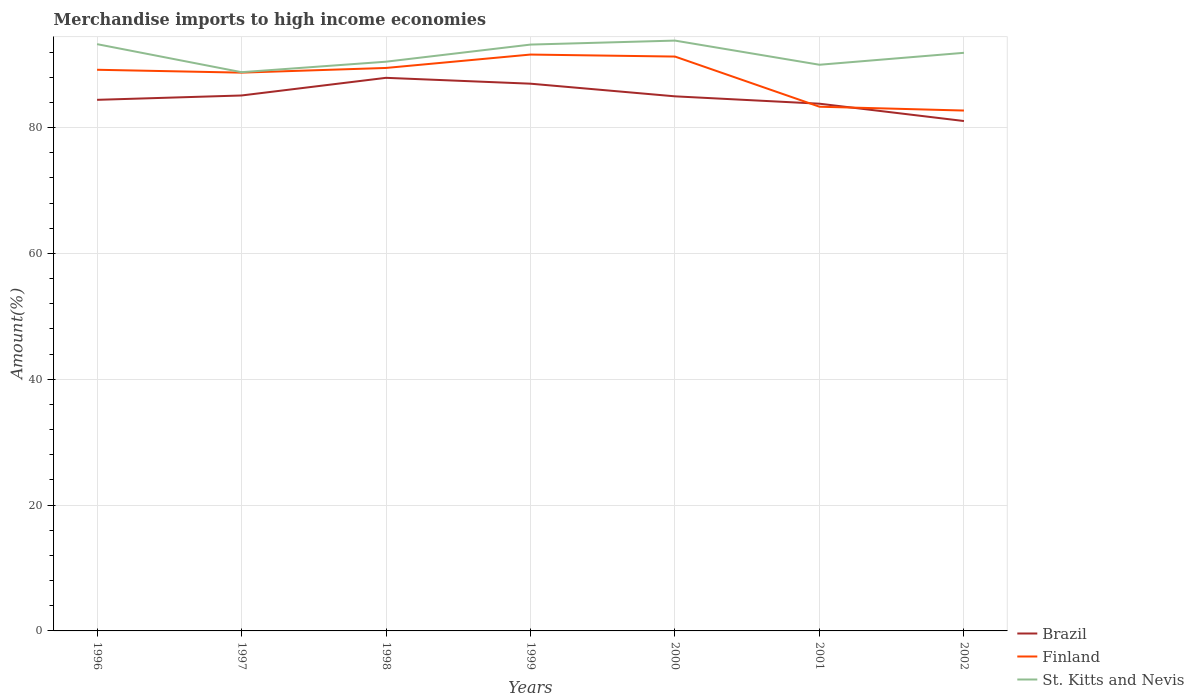How many different coloured lines are there?
Make the answer very short. 3. Does the line corresponding to Brazil intersect with the line corresponding to Finland?
Your response must be concise. Yes. Across all years, what is the maximum percentage of amount earned from merchandise imports in St. Kitts and Nevis?
Offer a terse response. 88.8. In which year was the percentage of amount earned from merchandise imports in Brazil maximum?
Offer a terse response. 2002. What is the total percentage of amount earned from merchandise imports in Brazil in the graph?
Your response must be concise. 0.14. What is the difference between the highest and the second highest percentage of amount earned from merchandise imports in St. Kitts and Nevis?
Your answer should be compact. 5.02. How many lines are there?
Provide a short and direct response. 3. How many years are there in the graph?
Keep it short and to the point. 7. Where does the legend appear in the graph?
Your response must be concise. Bottom right. How many legend labels are there?
Offer a terse response. 3. What is the title of the graph?
Your answer should be very brief. Merchandise imports to high income economies. What is the label or title of the X-axis?
Your answer should be compact. Years. What is the label or title of the Y-axis?
Ensure brevity in your answer.  Amount(%). What is the Amount(%) of Brazil in 1996?
Provide a short and direct response. 84.4. What is the Amount(%) of Finland in 1996?
Offer a very short reply. 89.18. What is the Amount(%) in St. Kitts and Nevis in 1996?
Your response must be concise. 93.25. What is the Amount(%) of Brazil in 1997?
Provide a short and direct response. 85.1. What is the Amount(%) of Finland in 1997?
Provide a succinct answer. 88.73. What is the Amount(%) in St. Kitts and Nevis in 1997?
Your response must be concise. 88.8. What is the Amount(%) in Brazil in 1998?
Make the answer very short. 87.9. What is the Amount(%) of Finland in 1998?
Offer a very short reply. 89.47. What is the Amount(%) in St. Kitts and Nevis in 1998?
Give a very brief answer. 90.46. What is the Amount(%) of Brazil in 1999?
Give a very brief answer. 86.97. What is the Amount(%) in Finland in 1999?
Your response must be concise. 91.6. What is the Amount(%) of St. Kitts and Nevis in 1999?
Your answer should be compact. 93.18. What is the Amount(%) in Brazil in 2000?
Your response must be concise. 84.96. What is the Amount(%) in Finland in 2000?
Provide a short and direct response. 91.28. What is the Amount(%) in St. Kitts and Nevis in 2000?
Ensure brevity in your answer.  93.82. What is the Amount(%) of Brazil in 2001?
Offer a very short reply. 83.79. What is the Amount(%) of Finland in 2001?
Give a very brief answer. 83.31. What is the Amount(%) in St. Kitts and Nevis in 2001?
Provide a succinct answer. 89.98. What is the Amount(%) of Brazil in 2002?
Offer a terse response. 81.04. What is the Amount(%) of Finland in 2002?
Give a very brief answer. 82.7. What is the Amount(%) of St. Kitts and Nevis in 2002?
Your answer should be very brief. 91.88. Across all years, what is the maximum Amount(%) in Brazil?
Your response must be concise. 87.9. Across all years, what is the maximum Amount(%) of Finland?
Provide a short and direct response. 91.6. Across all years, what is the maximum Amount(%) of St. Kitts and Nevis?
Provide a short and direct response. 93.82. Across all years, what is the minimum Amount(%) of Brazil?
Your answer should be very brief. 81.04. Across all years, what is the minimum Amount(%) of Finland?
Provide a succinct answer. 82.7. Across all years, what is the minimum Amount(%) of St. Kitts and Nevis?
Your answer should be very brief. 88.8. What is the total Amount(%) of Brazil in the graph?
Ensure brevity in your answer.  594.15. What is the total Amount(%) in Finland in the graph?
Give a very brief answer. 616.27. What is the total Amount(%) of St. Kitts and Nevis in the graph?
Give a very brief answer. 641.38. What is the difference between the Amount(%) in Brazil in 1996 and that in 1997?
Provide a succinct answer. -0.69. What is the difference between the Amount(%) in Finland in 1996 and that in 1997?
Your response must be concise. 0.46. What is the difference between the Amount(%) in St. Kitts and Nevis in 1996 and that in 1997?
Your answer should be very brief. 4.45. What is the difference between the Amount(%) of Brazil in 1996 and that in 1998?
Your answer should be very brief. -3.5. What is the difference between the Amount(%) of Finland in 1996 and that in 1998?
Provide a short and direct response. -0.29. What is the difference between the Amount(%) in St. Kitts and Nevis in 1996 and that in 1998?
Provide a short and direct response. 2.79. What is the difference between the Amount(%) of Brazil in 1996 and that in 1999?
Offer a terse response. -2.56. What is the difference between the Amount(%) of Finland in 1996 and that in 1999?
Keep it short and to the point. -2.42. What is the difference between the Amount(%) in St. Kitts and Nevis in 1996 and that in 1999?
Provide a short and direct response. 0.07. What is the difference between the Amount(%) of Brazil in 1996 and that in 2000?
Offer a very short reply. -0.56. What is the difference between the Amount(%) in Finland in 1996 and that in 2000?
Offer a terse response. -2.1. What is the difference between the Amount(%) in St. Kitts and Nevis in 1996 and that in 2000?
Give a very brief answer. -0.56. What is the difference between the Amount(%) in Brazil in 1996 and that in 2001?
Keep it short and to the point. 0.62. What is the difference between the Amount(%) in Finland in 1996 and that in 2001?
Your answer should be very brief. 5.87. What is the difference between the Amount(%) in St. Kitts and Nevis in 1996 and that in 2001?
Provide a short and direct response. 3.27. What is the difference between the Amount(%) of Brazil in 1996 and that in 2002?
Provide a short and direct response. 3.37. What is the difference between the Amount(%) in Finland in 1996 and that in 2002?
Ensure brevity in your answer.  6.48. What is the difference between the Amount(%) of St. Kitts and Nevis in 1996 and that in 2002?
Offer a terse response. 1.38. What is the difference between the Amount(%) in Brazil in 1997 and that in 1998?
Provide a short and direct response. -2.81. What is the difference between the Amount(%) of Finland in 1997 and that in 1998?
Offer a very short reply. -0.75. What is the difference between the Amount(%) of St. Kitts and Nevis in 1997 and that in 1998?
Provide a short and direct response. -1.67. What is the difference between the Amount(%) in Brazil in 1997 and that in 1999?
Offer a very short reply. -1.87. What is the difference between the Amount(%) of Finland in 1997 and that in 1999?
Ensure brevity in your answer.  -2.87. What is the difference between the Amount(%) of St. Kitts and Nevis in 1997 and that in 1999?
Ensure brevity in your answer.  -4.39. What is the difference between the Amount(%) of Brazil in 1997 and that in 2000?
Make the answer very short. 0.14. What is the difference between the Amount(%) of Finland in 1997 and that in 2000?
Provide a short and direct response. -2.55. What is the difference between the Amount(%) in St. Kitts and Nevis in 1997 and that in 2000?
Give a very brief answer. -5.02. What is the difference between the Amount(%) of Brazil in 1997 and that in 2001?
Your answer should be very brief. 1.31. What is the difference between the Amount(%) of Finland in 1997 and that in 2001?
Offer a terse response. 5.42. What is the difference between the Amount(%) of St. Kitts and Nevis in 1997 and that in 2001?
Provide a short and direct response. -1.18. What is the difference between the Amount(%) of Brazil in 1997 and that in 2002?
Provide a succinct answer. 4.06. What is the difference between the Amount(%) in Finland in 1997 and that in 2002?
Give a very brief answer. 6.02. What is the difference between the Amount(%) in St. Kitts and Nevis in 1997 and that in 2002?
Ensure brevity in your answer.  -3.08. What is the difference between the Amount(%) of Brazil in 1998 and that in 1999?
Provide a succinct answer. 0.93. What is the difference between the Amount(%) in Finland in 1998 and that in 1999?
Keep it short and to the point. -2.13. What is the difference between the Amount(%) of St. Kitts and Nevis in 1998 and that in 1999?
Provide a short and direct response. -2.72. What is the difference between the Amount(%) of Brazil in 1998 and that in 2000?
Offer a terse response. 2.94. What is the difference between the Amount(%) in Finland in 1998 and that in 2000?
Offer a very short reply. -1.81. What is the difference between the Amount(%) in St. Kitts and Nevis in 1998 and that in 2000?
Provide a short and direct response. -3.35. What is the difference between the Amount(%) of Brazil in 1998 and that in 2001?
Provide a short and direct response. 4.11. What is the difference between the Amount(%) in Finland in 1998 and that in 2001?
Keep it short and to the point. 6.16. What is the difference between the Amount(%) of St. Kitts and Nevis in 1998 and that in 2001?
Make the answer very short. 0.48. What is the difference between the Amount(%) in Brazil in 1998 and that in 2002?
Ensure brevity in your answer.  6.87. What is the difference between the Amount(%) in Finland in 1998 and that in 2002?
Make the answer very short. 6.77. What is the difference between the Amount(%) of St. Kitts and Nevis in 1998 and that in 2002?
Your answer should be compact. -1.41. What is the difference between the Amount(%) of Brazil in 1999 and that in 2000?
Provide a succinct answer. 2.01. What is the difference between the Amount(%) in Finland in 1999 and that in 2000?
Provide a succinct answer. 0.32. What is the difference between the Amount(%) in St. Kitts and Nevis in 1999 and that in 2000?
Your response must be concise. -0.63. What is the difference between the Amount(%) of Brazil in 1999 and that in 2001?
Your answer should be compact. 3.18. What is the difference between the Amount(%) of Finland in 1999 and that in 2001?
Offer a very short reply. 8.29. What is the difference between the Amount(%) of St. Kitts and Nevis in 1999 and that in 2001?
Provide a short and direct response. 3.2. What is the difference between the Amount(%) of Brazil in 1999 and that in 2002?
Your response must be concise. 5.93. What is the difference between the Amount(%) in Finland in 1999 and that in 2002?
Ensure brevity in your answer.  8.9. What is the difference between the Amount(%) of St. Kitts and Nevis in 1999 and that in 2002?
Offer a very short reply. 1.31. What is the difference between the Amount(%) of Brazil in 2000 and that in 2001?
Provide a succinct answer. 1.17. What is the difference between the Amount(%) of Finland in 2000 and that in 2001?
Your answer should be very brief. 7.97. What is the difference between the Amount(%) in St. Kitts and Nevis in 2000 and that in 2001?
Provide a succinct answer. 3.84. What is the difference between the Amount(%) in Brazil in 2000 and that in 2002?
Give a very brief answer. 3.92. What is the difference between the Amount(%) of Finland in 2000 and that in 2002?
Your answer should be very brief. 8.58. What is the difference between the Amount(%) of St. Kitts and Nevis in 2000 and that in 2002?
Make the answer very short. 1.94. What is the difference between the Amount(%) in Brazil in 2001 and that in 2002?
Provide a succinct answer. 2.75. What is the difference between the Amount(%) in Finland in 2001 and that in 2002?
Offer a terse response. 0.61. What is the difference between the Amount(%) of St. Kitts and Nevis in 2001 and that in 2002?
Provide a succinct answer. -1.9. What is the difference between the Amount(%) of Brazil in 1996 and the Amount(%) of Finland in 1997?
Offer a terse response. -4.32. What is the difference between the Amount(%) in Brazil in 1996 and the Amount(%) in St. Kitts and Nevis in 1997?
Keep it short and to the point. -4.39. What is the difference between the Amount(%) in Finland in 1996 and the Amount(%) in St. Kitts and Nevis in 1997?
Give a very brief answer. 0.38. What is the difference between the Amount(%) in Brazil in 1996 and the Amount(%) in Finland in 1998?
Your response must be concise. -5.07. What is the difference between the Amount(%) in Brazil in 1996 and the Amount(%) in St. Kitts and Nevis in 1998?
Offer a terse response. -6.06. What is the difference between the Amount(%) in Finland in 1996 and the Amount(%) in St. Kitts and Nevis in 1998?
Provide a succinct answer. -1.28. What is the difference between the Amount(%) of Brazil in 1996 and the Amount(%) of Finland in 1999?
Your response must be concise. -7.2. What is the difference between the Amount(%) of Brazil in 1996 and the Amount(%) of St. Kitts and Nevis in 1999?
Provide a short and direct response. -8.78. What is the difference between the Amount(%) in Finland in 1996 and the Amount(%) in St. Kitts and Nevis in 1999?
Offer a terse response. -4. What is the difference between the Amount(%) of Brazil in 1996 and the Amount(%) of Finland in 2000?
Your answer should be compact. -6.88. What is the difference between the Amount(%) in Brazil in 1996 and the Amount(%) in St. Kitts and Nevis in 2000?
Provide a short and direct response. -9.41. What is the difference between the Amount(%) of Finland in 1996 and the Amount(%) of St. Kitts and Nevis in 2000?
Offer a terse response. -4.64. What is the difference between the Amount(%) in Brazil in 1996 and the Amount(%) in Finland in 2001?
Keep it short and to the point. 1.09. What is the difference between the Amount(%) of Brazil in 1996 and the Amount(%) of St. Kitts and Nevis in 2001?
Provide a short and direct response. -5.58. What is the difference between the Amount(%) of Finland in 1996 and the Amount(%) of St. Kitts and Nevis in 2001?
Provide a short and direct response. -0.8. What is the difference between the Amount(%) of Brazil in 1996 and the Amount(%) of Finland in 2002?
Your response must be concise. 1.7. What is the difference between the Amount(%) in Brazil in 1996 and the Amount(%) in St. Kitts and Nevis in 2002?
Your response must be concise. -7.47. What is the difference between the Amount(%) in Finland in 1996 and the Amount(%) in St. Kitts and Nevis in 2002?
Make the answer very short. -2.7. What is the difference between the Amount(%) in Brazil in 1997 and the Amount(%) in Finland in 1998?
Your answer should be very brief. -4.38. What is the difference between the Amount(%) in Brazil in 1997 and the Amount(%) in St. Kitts and Nevis in 1998?
Ensure brevity in your answer.  -5.37. What is the difference between the Amount(%) in Finland in 1997 and the Amount(%) in St. Kitts and Nevis in 1998?
Your answer should be compact. -1.74. What is the difference between the Amount(%) in Brazil in 1997 and the Amount(%) in Finland in 1999?
Offer a terse response. -6.5. What is the difference between the Amount(%) in Brazil in 1997 and the Amount(%) in St. Kitts and Nevis in 1999?
Give a very brief answer. -8.09. What is the difference between the Amount(%) of Finland in 1997 and the Amount(%) of St. Kitts and Nevis in 1999?
Provide a succinct answer. -4.46. What is the difference between the Amount(%) in Brazil in 1997 and the Amount(%) in Finland in 2000?
Your response must be concise. -6.18. What is the difference between the Amount(%) of Brazil in 1997 and the Amount(%) of St. Kitts and Nevis in 2000?
Ensure brevity in your answer.  -8.72. What is the difference between the Amount(%) in Finland in 1997 and the Amount(%) in St. Kitts and Nevis in 2000?
Provide a short and direct response. -5.09. What is the difference between the Amount(%) in Brazil in 1997 and the Amount(%) in Finland in 2001?
Offer a terse response. 1.79. What is the difference between the Amount(%) of Brazil in 1997 and the Amount(%) of St. Kitts and Nevis in 2001?
Ensure brevity in your answer.  -4.88. What is the difference between the Amount(%) in Finland in 1997 and the Amount(%) in St. Kitts and Nevis in 2001?
Your response must be concise. -1.25. What is the difference between the Amount(%) in Brazil in 1997 and the Amount(%) in Finland in 2002?
Give a very brief answer. 2.39. What is the difference between the Amount(%) in Brazil in 1997 and the Amount(%) in St. Kitts and Nevis in 2002?
Your answer should be very brief. -6.78. What is the difference between the Amount(%) in Finland in 1997 and the Amount(%) in St. Kitts and Nevis in 2002?
Offer a very short reply. -3.15. What is the difference between the Amount(%) in Brazil in 1998 and the Amount(%) in Finland in 1999?
Offer a terse response. -3.7. What is the difference between the Amount(%) of Brazil in 1998 and the Amount(%) of St. Kitts and Nevis in 1999?
Ensure brevity in your answer.  -5.28. What is the difference between the Amount(%) of Finland in 1998 and the Amount(%) of St. Kitts and Nevis in 1999?
Your answer should be compact. -3.71. What is the difference between the Amount(%) in Brazil in 1998 and the Amount(%) in Finland in 2000?
Make the answer very short. -3.38. What is the difference between the Amount(%) of Brazil in 1998 and the Amount(%) of St. Kitts and Nevis in 2000?
Make the answer very short. -5.92. What is the difference between the Amount(%) in Finland in 1998 and the Amount(%) in St. Kitts and Nevis in 2000?
Your response must be concise. -4.35. What is the difference between the Amount(%) in Brazil in 1998 and the Amount(%) in Finland in 2001?
Your answer should be compact. 4.59. What is the difference between the Amount(%) in Brazil in 1998 and the Amount(%) in St. Kitts and Nevis in 2001?
Your response must be concise. -2.08. What is the difference between the Amount(%) of Finland in 1998 and the Amount(%) of St. Kitts and Nevis in 2001?
Ensure brevity in your answer.  -0.51. What is the difference between the Amount(%) in Brazil in 1998 and the Amount(%) in Finland in 2002?
Your response must be concise. 5.2. What is the difference between the Amount(%) of Brazil in 1998 and the Amount(%) of St. Kitts and Nevis in 2002?
Keep it short and to the point. -3.98. What is the difference between the Amount(%) of Finland in 1998 and the Amount(%) of St. Kitts and Nevis in 2002?
Offer a terse response. -2.41. What is the difference between the Amount(%) in Brazil in 1999 and the Amount(%) in Finland in 2000?
Make the answer very short. -4.31. What is the difference between the Amount(%) in Brazil in 1999 and the Amount(%) in St. Kitts and Nevis in 2000?
Ensure brevity in your answer.  -6.85. What is the difference between the Amount(%) in Finland in 1999 and the Amount(%) in St. Kitts and Nevis in 2000?
Keep it short and to the point. -2.22. What is the difference between the Amount(%) in Brazil in 1999 and the Amount(%) in Finland in 2001?
Offer a terse response. 3.66. What is the difference between the Amount(%) in Brazil in 1999 and the Amount(%) in St. Kitts and Nevis in 2001?
Provide a short and direct response. -3.01. What is the difference between the Amount(%) of Finland in 1999 and the Amount(%) of St. Kitts and Nevis in 2001?
Provide a succinct answer. 1.62. What is the difference between the Amount(%) of Brazil in 1999 and the Amount(%) of Finland in 2002?
Offer a terse response. 4.27. What is the difference between the Amount(%) of Brazil in 1999 and the Amount(%) of St. Kitts and Nevis in 2002?
Give a very brief answer. -4.91. What is the difference between the Amount(%) of Finland in 1999 and the Amount(%) of St. Kitts and Nevis in 2002?
Offer a very short reply. -0.28. What is the difference between the Amount(%) of Brazil in 2000 and the Amount(%) of Finland in 2001?
Provide a succinct answer. 1.65. What is the difference between the Amount(%) in Brazil in 2000 and the Amount(%) in St. Kitts and Nevis in 2001?
Provide a short and direct response. -5.02. What is the difference between the Amount(%) in Finland in 2000 and the Amount(%) in St. Kitts and Nevis in 2001?
Ensure brevity in your answer.  1.3. What is the difference between the Amount(%) in Brazil in 2000 and the Amount(%) in Finland in 2002?
Your answer should be very brief. 2.26. What is the difference between the Amount(%) of Brazil in 2000 and the Amount(%) of St. Kitts and Nevis in 2002?
Ensure brevity in your answer.  -6.92. What is the difference between the Amount(%) in Finland in 2000 and the Amount(%) in St. Kitts and Nevis in 2002?
Ensure brevity in your answer.  -0.6. What is the difference between the Amount(%) in Brazil in 2001 and the Amount(%) in Finland in 2002?
Your answer should be very brief. 1.09. What is the difference between the Amount(%) in Brazil in 2001 and the Amount(%) in St. Kitts and Nevis in 2002?
Offer a very short reply. -8.09. What is the difference between the Amount(%) in Finland in 2001 and the Amount(%) in St. Kitts and Nevis in 2002?
Give a very brief answer. -8.57. What is the average Amount(%) of Brazil per year?
Keep it short and to the point. 84.88. What is the average Amount(%) in Finland per year?
Your answer should be compact. 88.04. What is the average Amount(%) of St. Kitts and Nevis per year?
Make the answer very short. 91.63. In the year 1996, what is the difference between the Amount(%) of Brazil and Amount(%) of Finland?
Provide a succinct answer. -4.78. In the year 1996, what is the difference between the Amount(%) in Brazil and Amount(%) in St. Kitts and Nevis?
Provide a succinct answer. -8.85. In the year 1996, what is the difference between the Amount(%) in Finland and Amount(%) in St. Kitts and Nevis?
Give a very brief answer. -4.07. In the year 1997, what is the difference between the Amount(%) of Brazil and Amount(%) of Finland?
Ensure brevity in your answer.  -3.63. In the year 1997, what is the difference between the Amount(%) of Brazil and Amount(%) of St. Kitts and Nevis?
Give a very brief answer. -3.7. In the year 1997, what is the difference between the Amount(%) of Finland and Amount(%) of St. Kitts and Nevis?
Your answer should be very brief. -0.07. In the year 1998, what is the difference between the Amount(%) in Brazil and Amount(%) in Finland?
Keep it short and to the point. -1.57. In the year 1998, what is the difference between the Amount(%) in Brazil and Amount(%) in St. Kitts and Nevis?
Offer a terse response. -2.56. In the year 1998, what is the difference between the Amount(%) of Finland and Amount(%) of St. Kitts and Nevis?
Offer a very short reply. -0.99. In the year 1999, what is the difference between the Amount(%) in Brazil and Amount(%) in Finland?
Provide a short and direct response. -4.63. In the year 1999, what is the difference between the Amount(%) of Brazil and Amount(%) of St. Kitts and Nevis?
Your response must be concise. -6.21. In the year 1999, what is the difference between the Amount(%) of Finland and Amount(%) of St. Kitts and Nevis?
Ensure brevity in your answer.  -1.58. In the year 2000, what is the difference between the Amount(%) of Brazil and Amount(%) of Finland?
Provide a short and direct response. -6.32. In the year 2000, what is the difference between the Amount(%) of Brazil and Amount(%) of St. Kitts and Nevis?
Provide a short and direct response. -8.86. In the year 2000, what is the difference between the Amount(%) of Finland and Amount(%) of St. Kitts and Nevis?
Your answer should be very brief. -2.54. In the year 2001, what is the difference between the Amount(%) in Brazil and Amount(%) in Finland?
Your answer should be very brief. 0.48. In the year 2001, what is the difference between the Amount(%) in Brazil and Amount(%) in St. Kitts and Nevis?
Your answer should be compact. -6.19. In the year 2001, what is the difference between the Amount(%) of Finland and Amount(%) of St. Kitts and Nevis?
Offer a terse response. -6.67. In the year 2002, what is the difference between the Amount(%) in Brazil and Amount(%) in Finland?
Your answer should be compact. -1.67. In the year 2002, what is the difference between the Amount(%) in Brazil and Amount(%) in St. Kitts and Nevis?
Provide a succinct answer. -10.84. In the year 2002, what is the difference between the Amount(%) of Finland and Amount(%) of St. Kitts and Nevis?
Your answer should be compact. -9.18. What is the ratio of the Amount(%) in Brazil in 1996 to that in 1997?
Your response must be concise. 0.99. What is the ratio of the Amount(%) in Finland in 1996 to that in 1997?
Ensure brevity in your answer.  1.01. What is the ratio of the Amount(%) in St. Kitts and Nevis in 1996 to that in 1997?
Ensure brevity in your answer.  1.05. What is the ratio of the Amount(%) in Brazil in 1996 to that in 1998?
Offer a terse response. 0.96. What is the ratio of the Amount(%) of Finland in 1996 to that in 1998?
Provide a succinct answer. 1. What is the ratio of the Amount(%) in St. Kitts and Nevis in 1996 to that in 1998?
Ensure brevity in your answer.  1.03. What is the ratio of the Amount(%) of Brazil in 1996 to that in 1999?
Your response must be concise. 0.97. What is the ratio of the Amount(%) in Finland in 1996 to that in 1999?
Make the answer very short. 0.97. What is the ratio of the Amount(%) of St. Kitts and Nevis in 1996 to that in 2000?
Your answer should be compact. 0.99. What is the ratio of the Amount(%) in Brazil in 1996 to that in 2001?
Make the answer very short. 1.01. What is the ratio of the Amount(%) in Finland in 1996 to that in 2001?
Ensure brevity in your answer.  1.07. What is the ratio of the Amount(%) in St. Kitts and Nevis in 1996 to that in 2001?
Ensure brevity in your answer.  1.04. What is the ratio of the Amount(%) of Brazil in 1996 to that in 2002?
Keep it short and to the point. 1.04. What is the ratio of the Amount(%) of Finland in 1996 to that in 2002?
Provide a succinct answer. 1.08. What is the ratio of the Amount(%) of Brazil in 1997 to that in 1998?
Offer a terse response. 0.97. What is the ratio of the Amount(%) in St. Kitts and Nevis in 1997 to that in 1998?
Give a very brief answer. 0.98. What is the ratio of the Amount(%) of Brazil in 1997 to that in 1999?
Offer a very short reply. 0.98. What is the ratio of the Amount(%) of Finland in 1997 to that in 1999?
Keep it short and to the point. 0.97. What is the ratio of the Amount(%) of St. Kitts and Nevis in 1997 to that in 1999?
Ensure brevity in your answer.  0.95. What is the ratio of the Amount(%) of Brazil in 1997 to that in 2000?
Your response must be concise. 1. What is the ratio of the Amount(%) in St. Kitts and Nevis in 1997 to that in 2000?
Your answer should be very brief. 0.95. What is the ratio of the Amount(%) of Brazil in 1997 to that in 2001?
Your answer should be compact. 1.02. What is the ratio of the Amount(%) of Finland in 1997 to that in 2001?
Give a very brief answer. 1.06. What is the ratio of the Amount(%) in St. Kitts and Nevis in 1997 to that in 2001?
Keep it short and to the point. 0.99. What is the ratio of the Amount(%) in Brazil in 1997 to that in 2002?
Ensure brevity in your answer.  1.05. What is the ratio of the Amount(%) in Finland in 1997 to that in 2002?
Your answer should be compact. 1.07. What is the ratio of the Amount(%) in St. Kitts and Nevis in 1997 to that in 2002?
Keep it short and to the point. 0.97. What is the ratio of the Amount(%) of Brazil in 1998 to that in 1999?
Your answer should be compact. 1.01. What is the ratio of the Amount(%) in Finland in 1998 to that in 1999?
Make the answer very short. 0.98. What is the ratio of the Amount(%) of St. Kitts and Nevis in 1998 to that in 1999?
Ensure brevity in your answer.  0.97. What is the ratio of the Amount(%) in Brazil in 1998 to that in 2000?
Make the answer very short. 1.03. What is the ratio of the Amount(%) of Finland in 1998 to that in 2000?
Your answer should be very brief. 0.98. What is the ratio of the Amount(%) of Brazil in 1998 to that in 2001?
Provide a succinct answer. 1.05. What is the ratio of the Amount(%) of Finland in 1998 to that in 2001?
Your response must be concise. 1.07. What is the ratio of the Amount(%) of St. Kitts and Nevis in 1998 to that in 2001?
Give a very brief answer. 1.01. What is the ratio of the Amount(%) of Brazil in 1998 to that in 2002?
Give a very brief answer. 1.08. What is the ratio of the Amount(%) in Finland in 1998 to that in 2002?
Give a very brief answer. 1.08. What is the ratio of the Amount(%) of St. Kitts and Nevis in 1998 to that in 2002?
Your response must be concise. 0.98. What is the ratio of the Amount(%) in Brazil in 1999 to that in 2000?
Your answer should be compact. 1.02. What is the ratio of the Amount(%) in Finland in 1999 to that in 2000?
Your answer should be very brief. 1. What is the ratio of the Amount(%) in Brazil in 1999 to that in 2001?
Your answer should be compact. 1.04. What is the ratio of the Amount(%) in Finland in 1999 to that in 2001?
Offer a very short reply. 1.1. What is the ratio of the Amount(%) of St. Kitts and Nevis in 1999 to that in 2001?
Provide a succinct answer. 1.04. What is the ratio of the Amount(%) of Brazil in 1999 to that in 2002?
Provide a short and direct response. 1.07. What is the ratio of the Amount(%) of Finland in 1999 to that in 2002?
Your answer should be very brief. 1.11. What is the ratio of the Amount(%) of St. Kitts and Nevis in 1999 to that in 2002?
Keep it short and to the point. 1.01. What is the ratio of the Amount(%) in Brazil in 2000 to that in 2001?
Keep it short and to the point. 1.01. What is the ratio of the Amount(%) in Finland in 2000 to that in 2001?
Keep it short and to the point. 1.1. What is the ratio of the Amount(%) of St. Kitts and Nevis in 2000 to that in 2001?
Ensure brevity in your answer.  1.04. What is the ratio of the Amount(%) in Brazil in 2000 to that in 2002?
Your response must be concise. 1.05. What is the ratio of the Amount(%) of Finland in 2000 to that in 2002?
Make the answer very short. 1.1. What is the ratio of the Amount(%) of St. Kitts and Nevis in 2000 to that in 2002?
Ensure brevity in your answer.  1.02. What is the ratio of the Amount(%) of Brazil in 2001 to that in 2002?
Offer a very short reply. 1.03. What is the ratio of the Amount(%) in Finland in 2001 to that in 2002?
Offer a terse response. 1.01. What is the ratio of the Amount(%) in St. Kitts and Nevis in 2001 to that in 2002?
Make the answer very short. 0.98. What is the difference between the highest and the second highest Amount(%) in Brazil?
Your response must be concise. 0.93. What is the difference between the highest and the second highest Amount(%) in Finland?
Keep it short and to the point. 0.32. What is the difference between the highest and the second highest Amount(%) in St. Kitts and Nevis?
Offer a terse response. 0.56. What is the difference between the highest and the lowest Amount(%) of Brazil?
Provide a short and direct response. 6.87. What is the difference between the highest and the lowest Amount(%) in Finland?
Your response must be concise. 8.9. What is the difference between the highest and the lowest Amount(%) of St. Kitts and Nevis?
Offer a terse response. 5.02. 